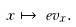Convert formula to latex. <formula><loc_0><loc_0><loc_500><loc_500>x & \mapsto \ e v _ { x } .</formula> 